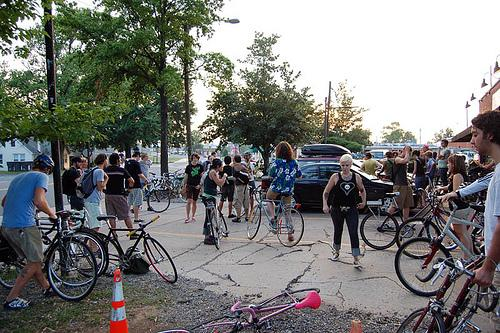Where would you normally find the orange and white thing in the foreground?

Choices:
A) playground
B) pub
C) beach
D) road road 